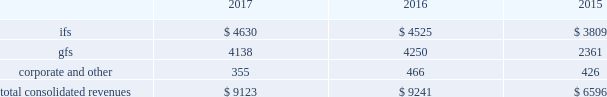2022 expand client relationships - the overall market we serve continues to gravitate beyond single-application purchases to multi-solution partnerships .
As the market dynamics shift , we expect our clients and prospects to rely more on our multidimensional service offerings .
Our leveraged solutions and processing expertise can produce meaningful value and cost savings for our clients through more efficient operating processes , improved service quality and convenience for our clients' customers .
2022 build global diversification - we continue to deploy resources in global markets where we expect to achieve meaningful scale .
Revenues by segment the table below summarizes our revenues by reporting segment ( in millions ) : .
Integrated financial solutions ( "ifs" ) the ifs segment is focused primarily on serving north american regional and community bank and savings institutions for transaction and account processing , payment solutions , channel solutions , digital channels , fraud , risk management and compliance solutions , lending and wealth and retirement solutions , and corporate liquidity , capitalizing on the continuing trend to outsource these solutions .
Clients in this segment include regional and community banks , credit unions and commercial lenders , as well as government institutions , merchants and other commercial organizations .
These markets are primarily served through integrated solutions and characterized by multi-year processing contracts that generate highly recurring revenues .
The predictable nature of cash flows generated from this segment provides opportunities for further investments in innovation , integration , information and security , and compliance in a cost-effective manner .
Our solutions in this segment include : 2022 core processing and ancillary applications .
Our core processing software applications are designed to run banking processes for our financial institution clients , including deposit and lending systems , customer management , and other central management systems , serving as the system of record for processed activity .
Our diverse selection of market- focused core systems enables fis to compete effectively in a wide range of markets .
We also offer a number of services that are ancillary to the primary applications listed above , including branch automation , back-office support systems and compliance support .
2022 digital solutions , including internet , mobile and ebanking .
Our comprehensive suite of retail delivery applications enables financial institutions to integrate and streamline customer-facing operations and back-office processes , thereby improving customer interaction across all channels ( e.g. , branch offices , internet , atm , mobile , call centers ) .
Fis' focus on consumer access has driven significant market innovation in this area , with multi-channel and multi-host solutions and a strategy that provides tight integration of services and a seamless customer experience .
Fis is a leader in mobile banking solutions and electronic banking enabling clients to manage banking and payments through the internet , mobile devices , accounting software and telephone .
Our corporate electronic banking solutions provide commercial treasury capabilities including cash management services and multi-bank collection and disbursement services that address the specialized needs of corporate clients .
Fis systems provide full accounting and reconciliation for such transactions , serving also as the system of record. .
What is the growth rate in revenues generated by the fis segment from 2016 to 2017? 
Computations: ((4630 - 4525) / 4525)
Answer: 0.0232. 